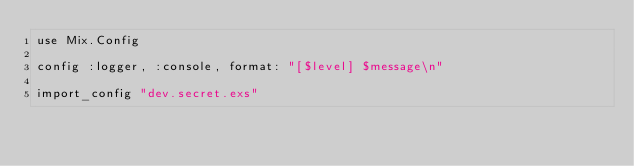Convert code to text. <code><loc_0><loc_0><loc_500><loc_500><_Elixir_>use Mix.Config

config :logger, :console, format: "[$level] $message\n"

import_config "dev.secret.exs"
</code> 